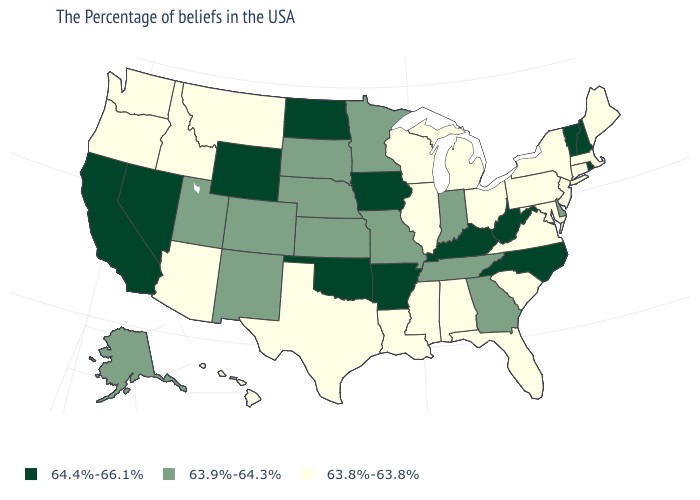What is the value of Washington?
Answer briefly. 63.8%-63.8%. What is the value of Wyoming?
Write a very short answer. 64.4%-66.1%. Does Nevada have the same value as North Carolina?
Give a very brief answer. Yes. What is the value of Alabama?
Give a very brief answer. 63.8%-63.8%. What is the highest value in the USA?
Quick response, please. 64.4%-66.1%. Name the states that have a value in the range 64.4%-66.1%?
Give a very brief answer. Rhode Island, New Hampshire, Vermont, North Carolina, West Virginia, Kentucky, Arkansas, Iowa, Oklahoma, North Dakota, Wyoming, Nevada, California. Name the states that have a value in the range 63.9%-64.3%?
Keep it brief. Delaware, Georgia, Indiana, Tennessee, Missouri, Minnesota, Kansas, Nebraska, South Dakota, Colorado, New Mexico, Utah, Alaska. Which states have the highest value in the USA?
Write a very short answer. Rhode Island, New Hampshire, Vermont, North Carolina, West Virginia, Kentucky, Arkansas, Iowa, Oklahoma, North Dakota, Wyoming, Nevada, California. Which states have the highest value in the USA?
Answer briefly. Rhode Island, New Hampshire, Vermont, North Carolina, West Virginia, Kentucky, Arkansas, Iowa, Oklahoma, North Dakota, Wyoming, Nevada, California. What is the value of South Dakota?
Be succinct. 63.9%-64.3%. What is the value of Florida?
Answer briefly. 63.8%-63.8%. Which states have the lowest value in the MidWest?
Write a very short answer. Ohio, Michigan, Wisconsin, Illinois. What is the lowest value in the West?
Short answer required. 63.8%-63.8%. What is the value of Mississippi?
Short answer required. 63.8%-63.8%. Name the states that have a value in the range 63.8%-63.8%?
Concise answer only. Maine, Massachusetts, Connecticut, New York, New Jersey, Maryland, Pennsylvania, Virginia, South Carolina, Ohio, Florida, Michigan, Alabama, Wisconsin, Illinois, Mississippi, Louisiana, Texas, Montana, Arizona, Idaho, Washington, Oregon, Hawaii. 